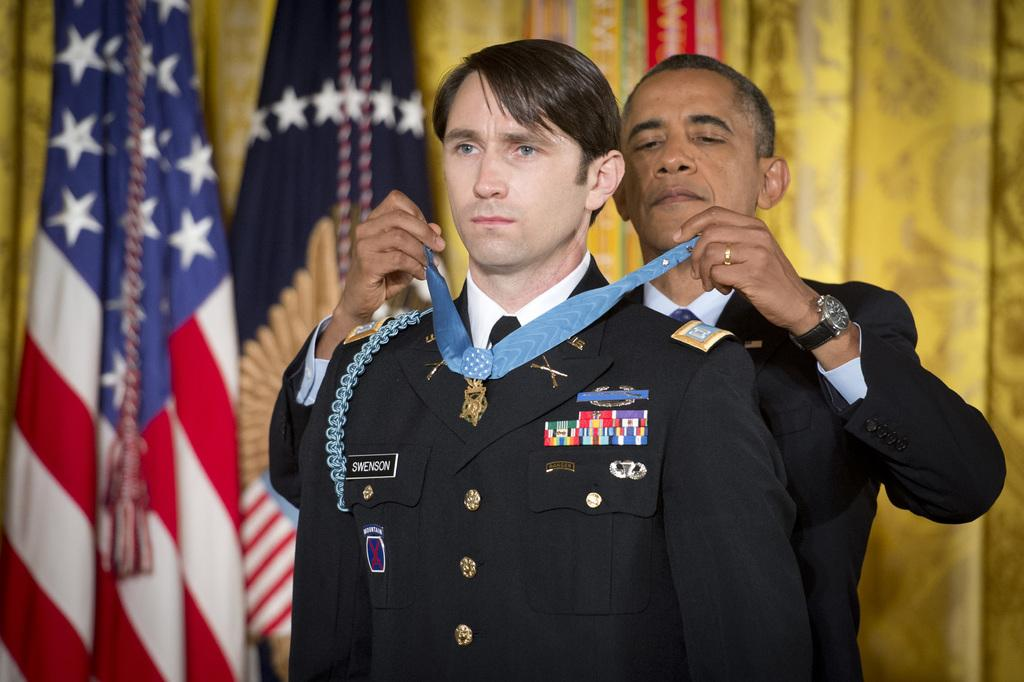<image>
Render a clear and concise summary of the photo. a man with the name Swenson getting a medal put around his neck 